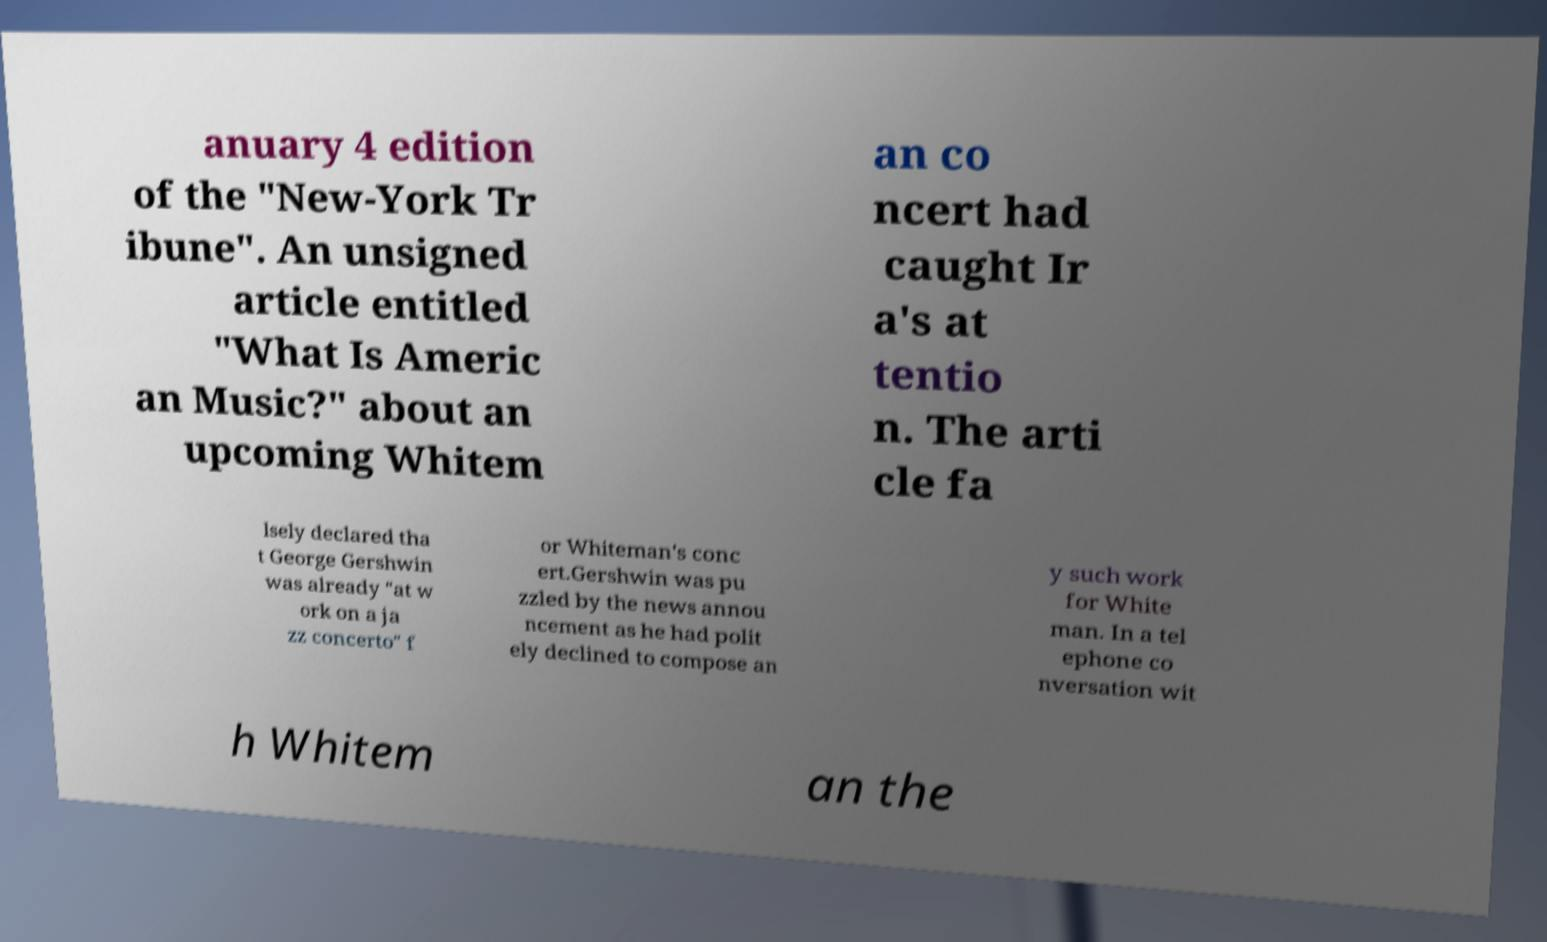For documentation purposes, I need the text within this image transcribed. Could you provide that? anuary 4 edition of the "New-York Tr ibune". An unsigned article entitled "What Is Americ an Music?" about an upcoming Whitem an co ncert had caught Ir a's at tentio n. The arti cle fa lsely declared tha t George Gershwin was already "at w ork on a ja zz concerto" f or Whiteman's conc ert.Gershwin was pu zzled by the news annou ncement as he had polit ely declined to compose an y such work for White man. In a tel ephone co nversation wit h Whitem an the 